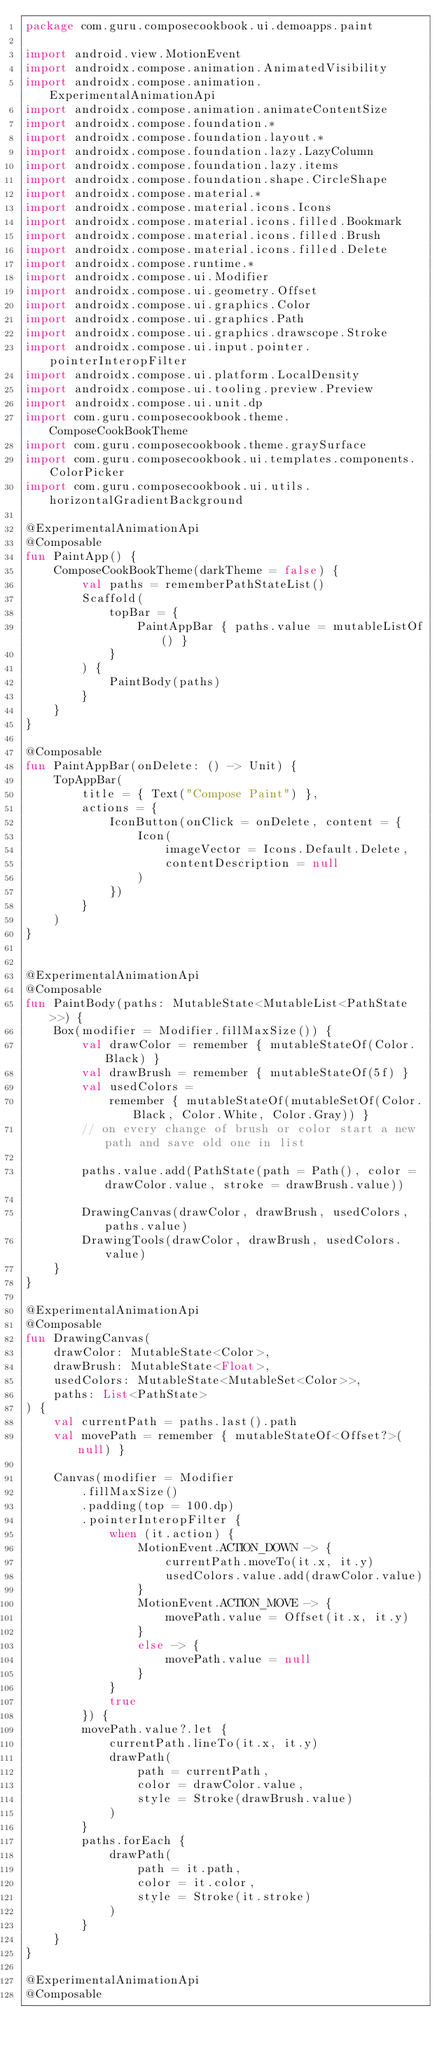Convert code to text. <code><loc_0><loc_0><loc_500><loc_500><_Kotlin_>package com.guru.composecookbook.ui.demoapps.paint

import android.view.MotionEvent
import androidx.compose.animation.AnimatedVisibility
import androidx.compose.animation.ExperimentalAnimationApi
import androidx.compose.animation.animateContentSize
import androidx.compose.foundation.*
import androidx.compose.foundation.layout.*
import androidx.compose.foundation.lazy.LazyColumn
import androidx.compose.foundation.lazy.items
import androidx.compose.foundation.shape.CircleShape
import androidx.compose.material.*
import androidx.compose.material.icons.Icons
import androidx.compose.material.icons.filled.Bookmark
import androidx.compose.material.icons.filled.Brush
import androidx.compose.material.icons.filled.Delete
import androidx.compose.runtime.*
import androidx.compose.ui.Modifier
import androidx.compose.ui.geometry.Offset
import androidx.compose.ui.graphics.Color
import androidx.compose.ui.graphics.Path
import androidx.compose.ui.graphics.drawscope.Stroke
import androidx.compose.ui.input.pointer.pointerInteropFilter
import androidx.compose.ui.platform.LocalDensity
import androidx.compose.ui.tooling.preview.Preview
import androidx.compose.ui.unit.dp
import com.guru.composecookbook.theme.ComposeCookBookTheme
import com.guru.composecookbook.theme.graySurface
import com.guru.composecookbook.ui.templates.components.ColorPicker
import com.guru.composecookbook.ui.utils.horizontalGradientBackground

@ExperimentalAnimationApi
@Composable
fun PaintApp() {
    ComposeCookBookTheme(darkTheme = false) {
        val paths = rememberPathStateList()
        Scaffold(
            topBar = {
                PaintAppBar { paths.value = mutableListOf() }
            }
        ) {
            PaintBody(paths)
        }
    }
}

@Composable
fun PaintAppBar(onDelete: () -> Unit) {
    TopAppBar(
        title = { Text("Compose Paint") },
        actions = {
            IconButton(onClick = onDelete, content = {
                Icon(
                    imageVector = Icons.Default.Delete,
                    contentDescription = null
                )
            })
        }
    )
}


@ExperimentalAnimationApi
@Composable
fun PaintBody(paths: MutableState<MutableList<PathState>>) {
    Box(modifier = Modifier.fillMaxSize()) {
        val drawColor = remember { mutableStateOf(Color.Black) }
        val drawBrush = remember { mutableStateOf(5f) }
        val usedColors =
            remember { mutableStateOf(mutableSetOf(Color.Black, Color.White, Color.Gray)) }
        // on every change of brush or color start a new path and save old one in list

        paths.value.add(PathState(path = Path(), color = drawColor.value, stroke = drawBrush.value))

        DrawingCanvas(drawColor, drawBrush, usedColors, paths.value)
        DrawingTools(drawColor, drawBrush, usedColors.value)
    }
}

@ExperimentalAnimationApi
@Composable
fun DrawingCanvas(
    drawColor: MutableState<Color>,
    drawBrush: MutableState<Float>,
    usedColors: MutableState<MutableSet<Color>>,
    paths: List<PathState>
) {
    val currentPath = paths.last().path
    val movePath = remember { mutableStateOf<Offset?>(null) }

    Canvas(modifier = Modifier
        .fillMaxSize()
        .padding(top = 100.dp)
        .pointerInteropFilter {
            when (it.action) {
                MotionEvent.ACTION_DOWN -> {
                    currentPath.moveTo(it.x, it.y)
                    usedColors.value.add(drawColor.value)
                }
                MotionEvent.ACTION_MOVE -> {
                    movePath.value = Offset(it.x, it.y)
                }
                else -> {
                    movePath.value = null
                }
            }
            true
        }) {
        movePath.value?.let {
            currentPath.lineTo(it.x, it.y)
            drawPath(
                path = currentPath,
                color = drawColor.value,
                style = Stroke(drawBrush.value)
            )
        }
        paths.forEach {
            drawPath(
                path = it.path,
                color = it.color,
                style = Stroke(it.stroke)
            )
        }
    }
}

@ExperimentalAnimationApi
@Composable</code> 